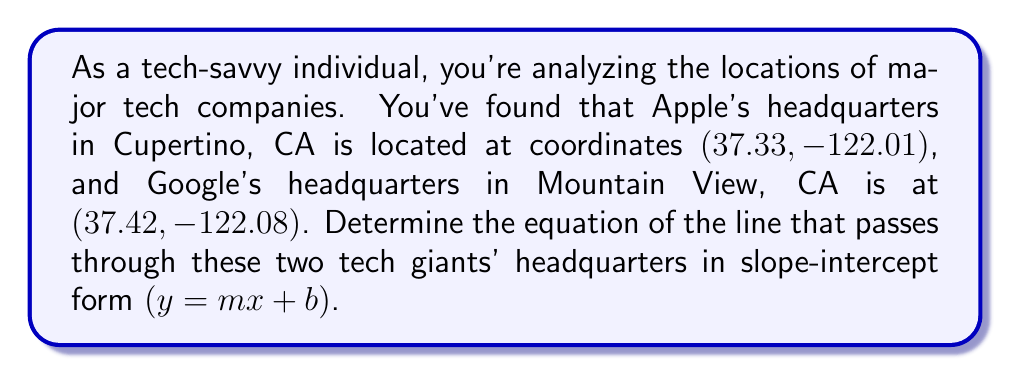Teach me how to tackle this problem. To find the equation of a line passing through two points, we can follow these steps:

1. Calculate the slope $(m)$ using the slope formula:
   $$m = \frac{y_2 - y_1}{x_2 - x_1}$$

   Where $(x_1, y_1)$ is Apple's coordinates and $(x_2, y_2)$ is Google's coordinates.

   $$m = \frac{37.42 - 37.33}{-122.08 - (-122.01)} = \frac{0.09}{-0.07} = -1.2857$$

2. Use the point-slope form of a line with either point and the calculated slope:
   $$y - y_1 = m(x - x_1)$$

   Let's use Apple's coordinates (37.33, -122.01):

   $$y - 37.33 = -1.2857(x - (-122.01))$$

3. Simplify and rearrange to slope-intercept form $(y = mx + b)$:
   $$y - 37.33 = -1.2857x - 156.8543$$
   $$y = -1.2857x - 156.8543 + 37.33$$
   $$y = -1.2857x - 119.5243$$

Therefore, the equation of the line passing through Apple and Google headquarters is:
$$y = -1.2857x - 119.5243$$
Answer: $y = -1.2857x - 119.5243$ 